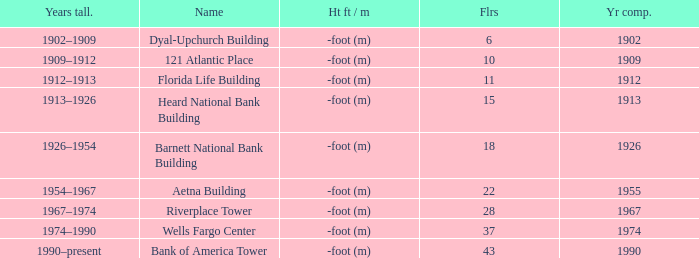What was the name of the building with 10 floors? 121 Atlantic Place. 